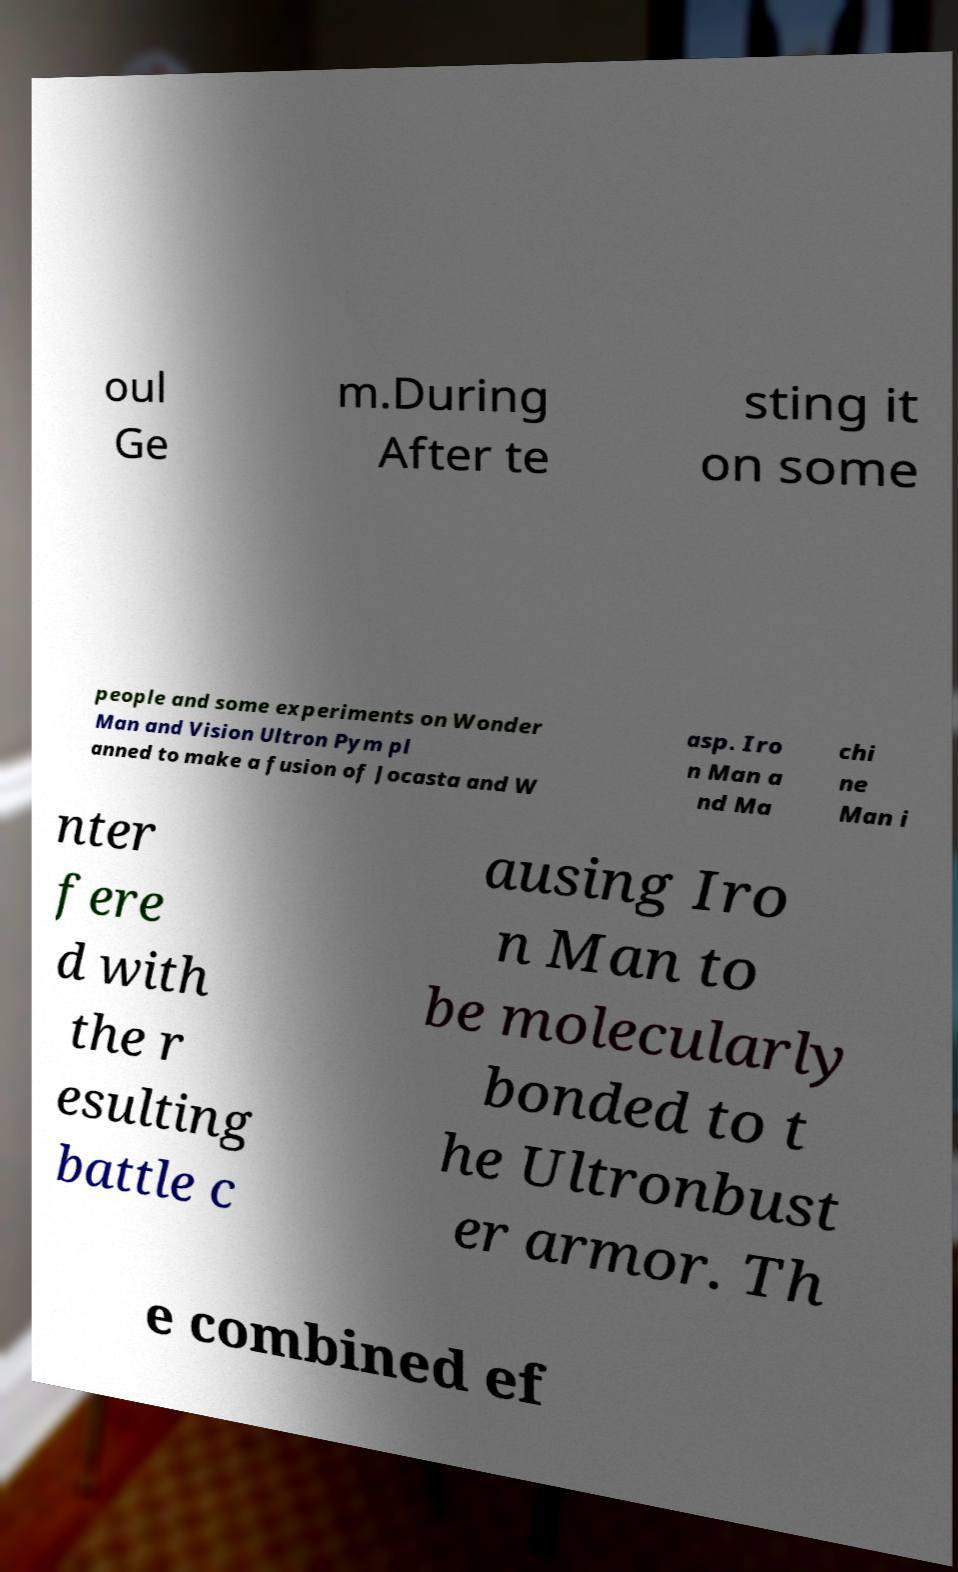For documentation purposes, I need the text within this image transcribed. Could you provide that? oul Ge m.During After te sting it on some people and some experiments on Wonder Man and Vision Ultron Pym pl anned to make a fusion of Jocasta and W asp. Iro n Man a nd Ma chi ne Man i nter fere d with the r esulting battle c ausing Iro n Man to be molecularly bonded to t he Ultronbust er armor. Th e combined ef 